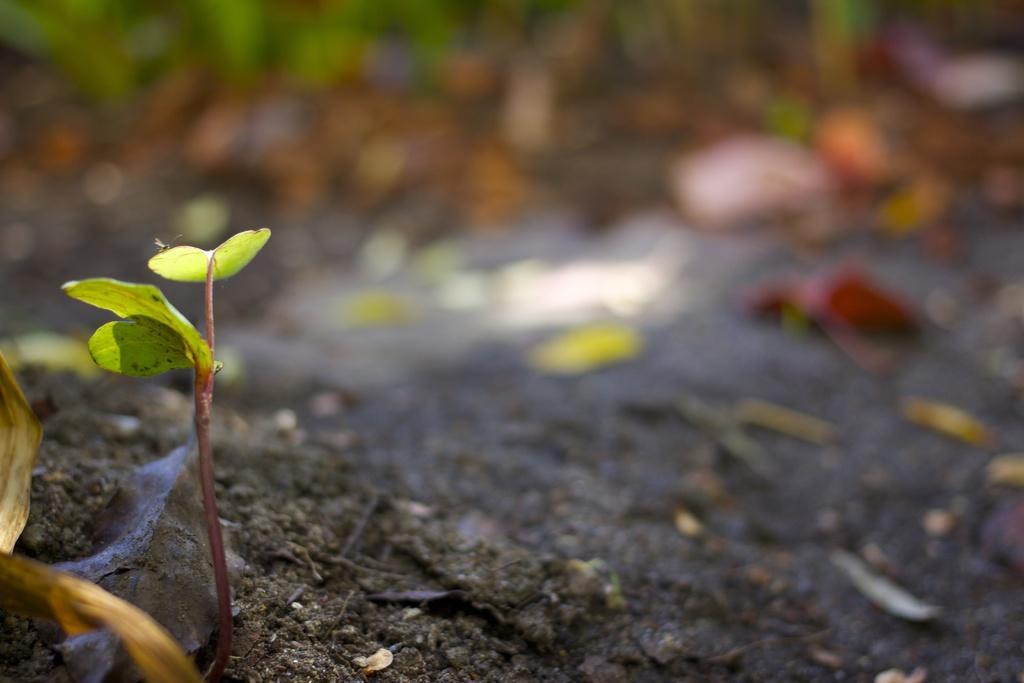In one or two sentences, can you explain what this image depicts? On the left side of the image we can see a seedling. At the bottom there is soil and we can see leaves. 